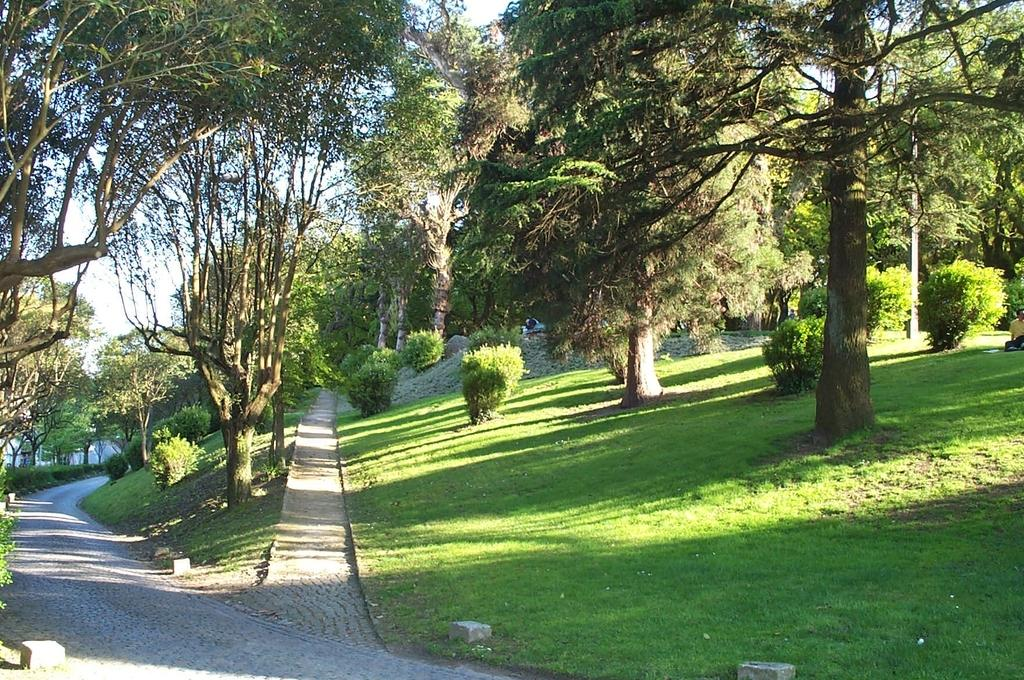What type of vegetation can be seen in the image? There are trees in the image. What is the color of the trees in the image? The trees are green in color. What else is visible in the image besides the trees? The sky is visible in the image. What is the color of the sky in the image? The sky is white in color. What type of prose can be seen in the image? There is no prose present in the image; it features trees and a white sky. What material is the relation made of in the image? There is no relation present in the image, and therefore no material can be associated with it. 